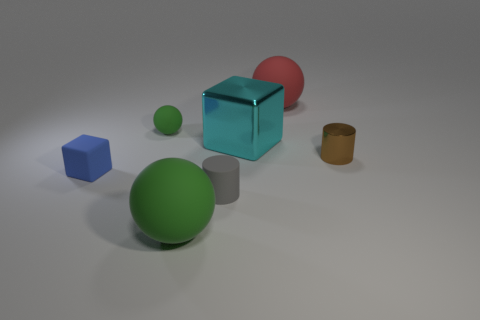Add 3 green rubber cylinders. How many objects exist? 10 Subtract all cylinders. How many objects are left? 5 Add 2 tiny purple shiny things. How many tiny purple shiny things exist? 2 Subtract 1 cyan cubes. How many objects are left? 6 Subtract all small green matte things. Subtract all large red rubber spheres. How many objects are left? 5 Add 7 tiny gray rubber cylinders. How many tiny gray rubber cylinders are left? 8 